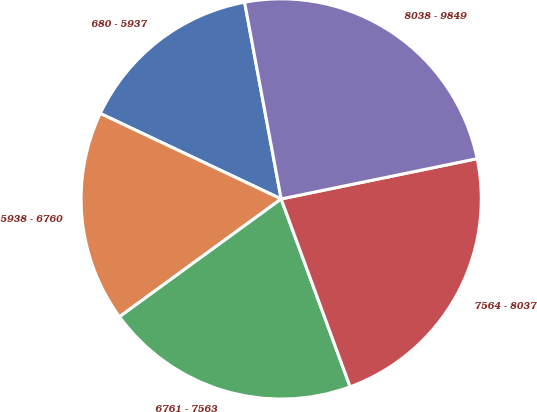<chart> <loc_0><loc_0><loc_500><loc_500><pie_chart><fcel>680 - 5937<fcel>5938 - 6760<fcel>6761 - 7563<fcel>7564 - 8037<fcel>8038 - 9849<nl><fcel>15.05%<fcel>17.05%<fcel>20.58%<fcel>22.63%<fcel>24.7%<nl></chart> 